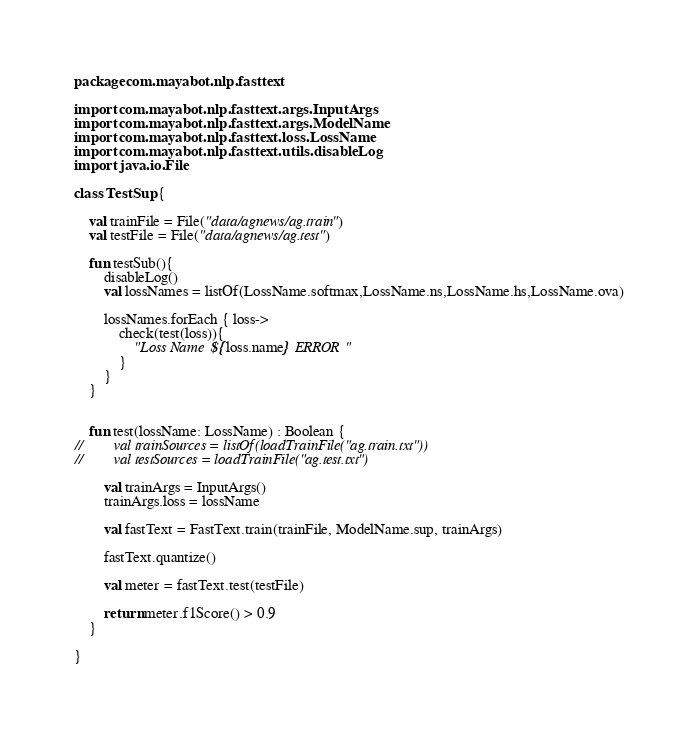Convert code to text. <code><loc_0><loc_0><loc_500><loc_500><_Kotlin_>package com.mayabot.nlp.fasttext

import com.mayabot.nlp.fasttext.args.InputArgs
import com.mayabot.nlp.fasttext.args.ModelName
import com.mayabot.nlp.fasttext.loss.LossName
import com.mayabot.nlp.fasttext.utils.disableLog
import java.io.File

class TestSup {

    val trainFile = File("data/agnews/ag.train")
    val testFile = File("data/agnews/ag.test")

    fun testSub(){
        disableLog()
        val lossNames = listOf(LossName.softmax,LossName.ns,LossName.hs,LossName.ova)

        lossNames.forEach { loss->
            check(test(loss)){
                "Loss Name ${loss.name} ERROR"
            }
        }
    }


    fun test(lossName: LossName) : Boolean {
//        val trainSources = listOf(loadTrainFile("ag.train.txt"))
//        val testSources = loadTrainFile("ag.test.txt")

        val trainArgs = InputArgs()
        trainArgs.loss = lossName

        val fastText = FastText.train(trainFile, ModelName.sup, trainArgs)

        fastText.quantize()

        val meter = fastText.test(testFile)

        return meter.f1Score() > 0.9
    }

}</code> 